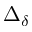Convert formula to latex. <formula><loc_0><loc_0><loc_500><loc_500>\Delta _ { \delta }</formula> 